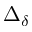Convert formula to latex. <formula><loc_0><loc_0><loc_500><loc_500>\Delta _ { \delta }</formula> 